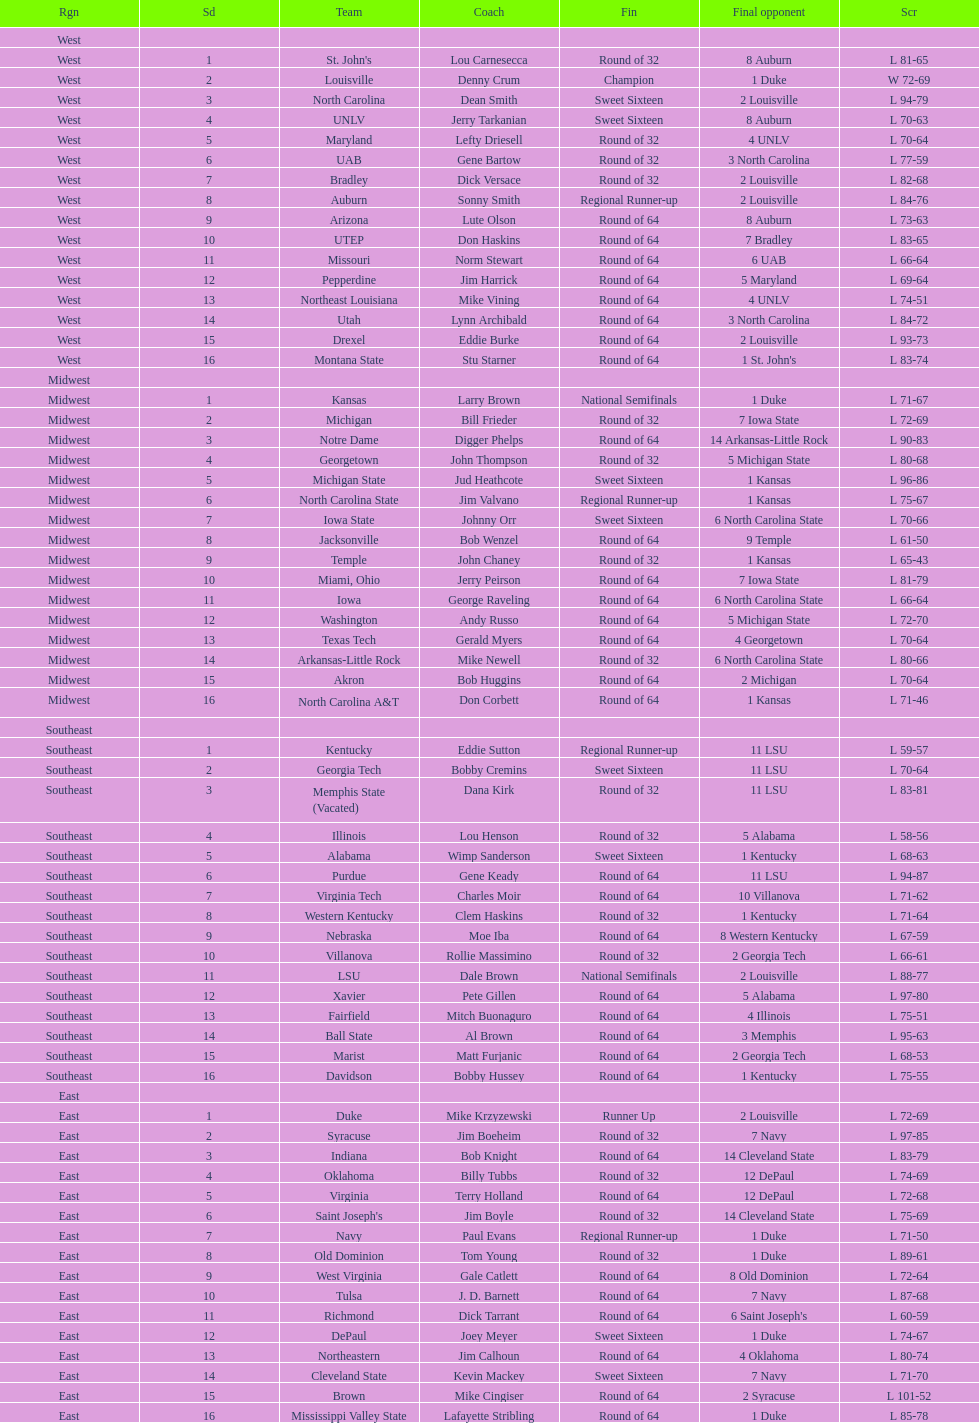North carolina and unlv each made it to which round? Sweet Sixteen. 